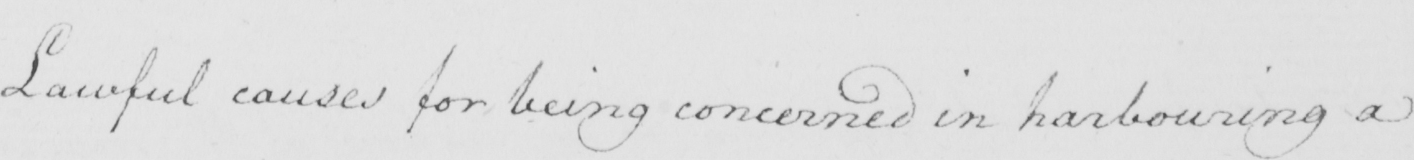What is written in this line of handwriting? Lawful causes for being concerned in harbouring a 